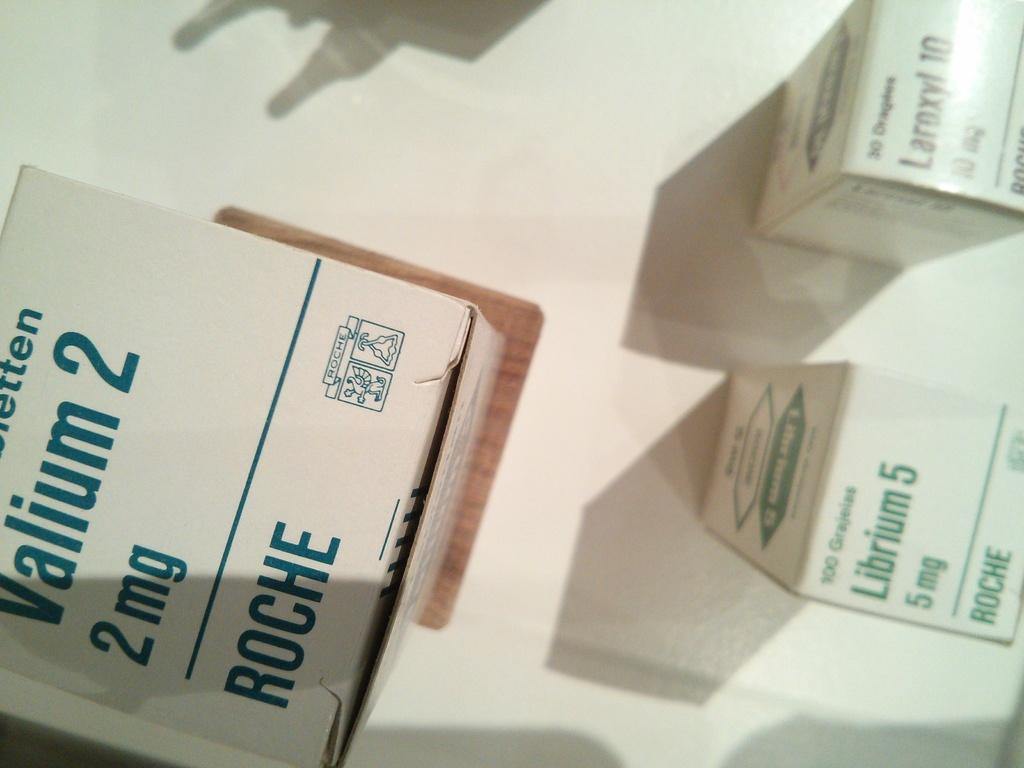How many milligrams are the valium2?
Offer a terse response. 2. What kind of medication is labeled on the box to the left?
Offer a very short reply. Valium. 